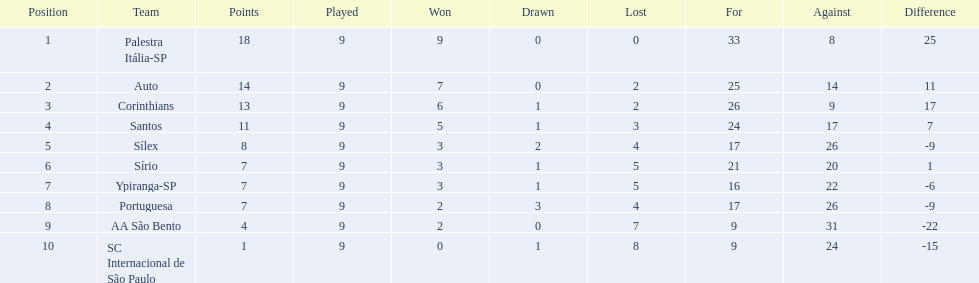What was the total number of points scored by all teams? 18, 14, 13, 11, 8, 7, 7, 7, 4, 1. Which team managed to score 13 points? Corinthians. 